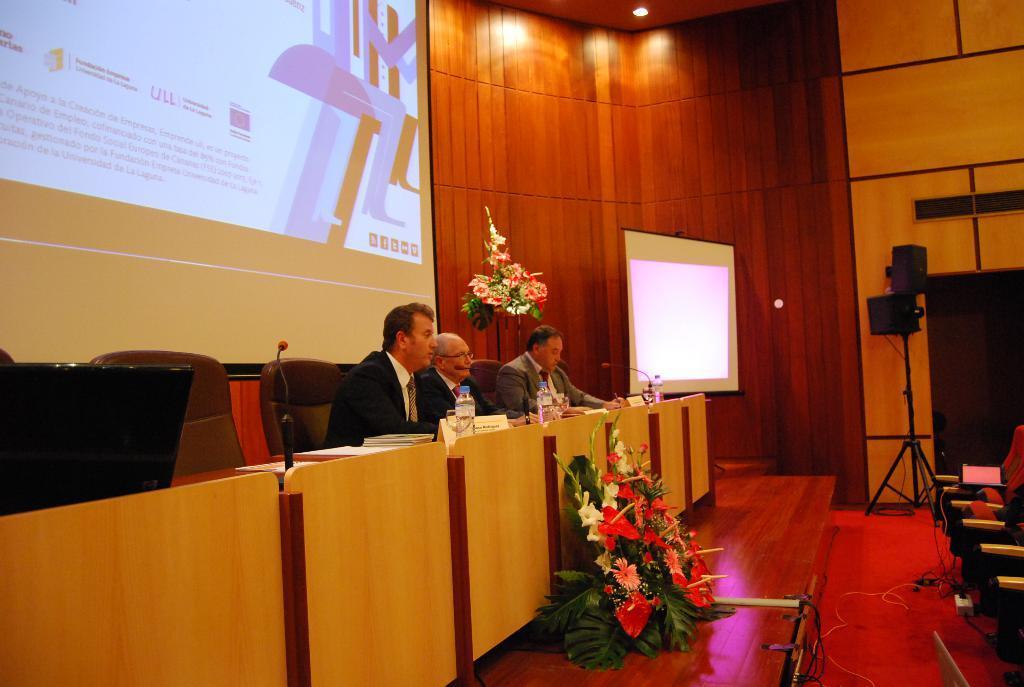Describe this image in one or two sentences. In this picture we can see a screen, flower bouquets, objects, speaker, stand, chairs, light and wires. On the left side of the picture we can see the projection of screen on the wall. We can see the people are sitting on the chairs. On a table we can see bottles, objects and microphones. 